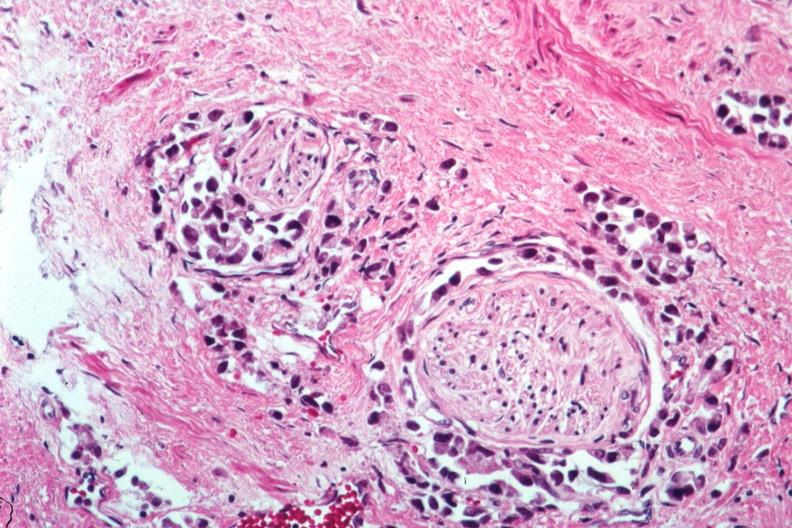what is present?
Answer the question using a single word or phrase. Prostate 